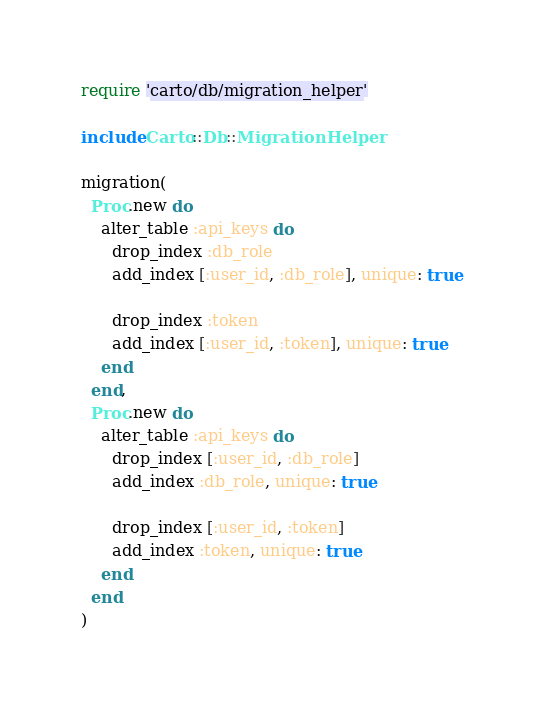<code> <loc_0><loc_0><loc_500><loc_500><_Ruby_>require 'carto/db/migration_helper'

include Carto::Db::MigrationHelper

migration(
  Proc.new do
    alter_table :api_keys do
      drop_index :db_role
      add_index [:user_id, :db_role], unique: true

      drop_index :token
      add_index [:user_id, :token], unique: true
    end
  end,
  Proc.new do
    alter_table :api_keys do
      drop_index [:user_id, :db_role]
      add_index :db_role, unique: true

      drop_index [:user_id, :token]
      add_index :token, unique: true
    end
  end
)
</code> 